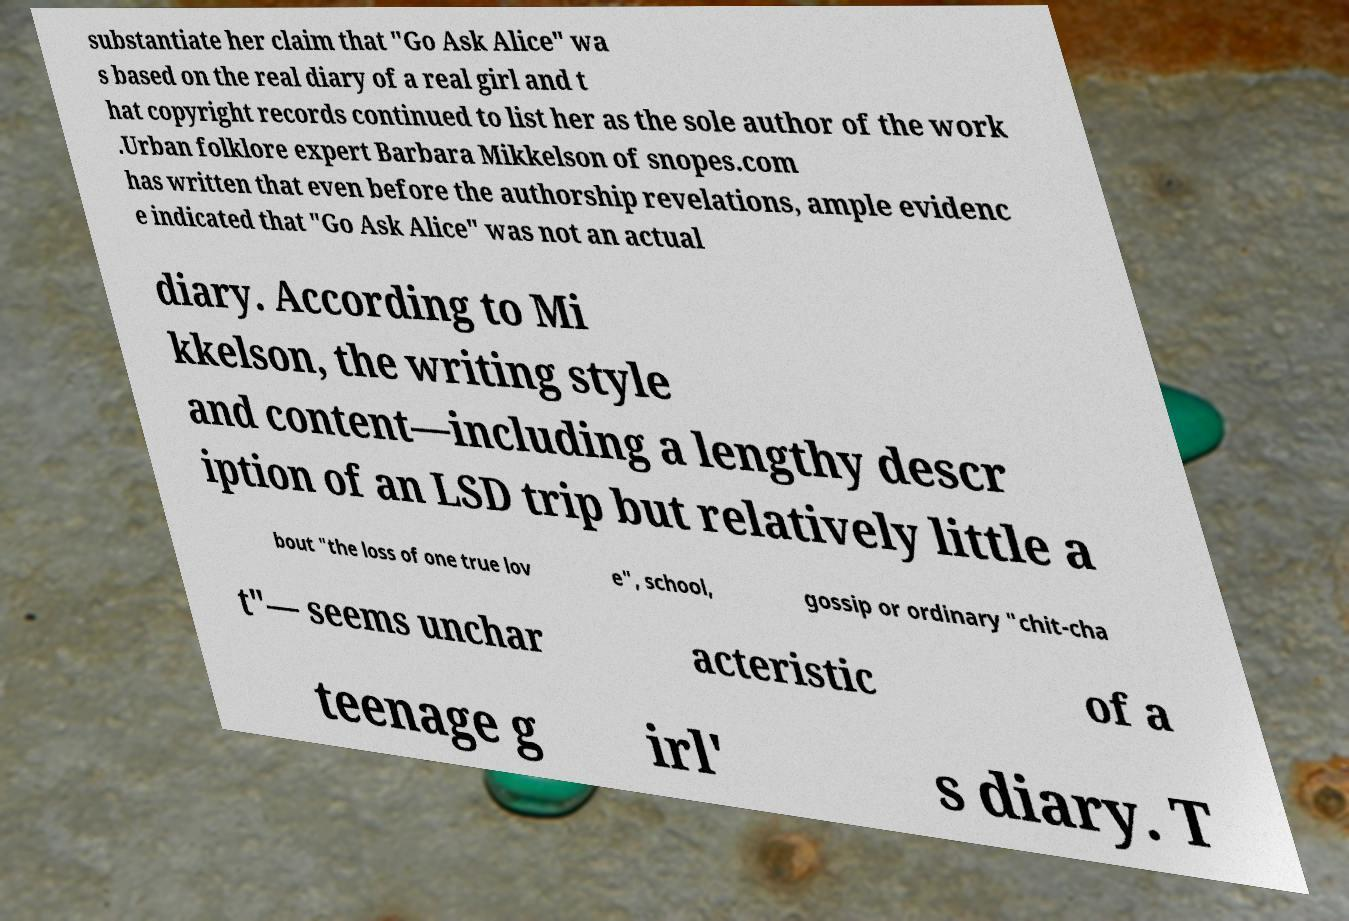Please read and relay the text visible in this image. What does it say? substantiate her claim that "Go Ask Alice" wa s based on the real diary of a real girl and t hat copyright records continued to list her as the sole author of the work .Urban folklore expert Barbara Mikkelson of snopes.com has written that even before the authorship revelations, ample evidenc e indicated that "Go Ask Alice" was not an actual diary. According to Mi kkelson, the writing style and content—including a lengthy descr iption of an LSD trip but relatively little a bout "the loss of one true lov e", school, gossip or ordinary "chit-cha t"— seems unchar acteristic of a teenage g irl' s diary. T 